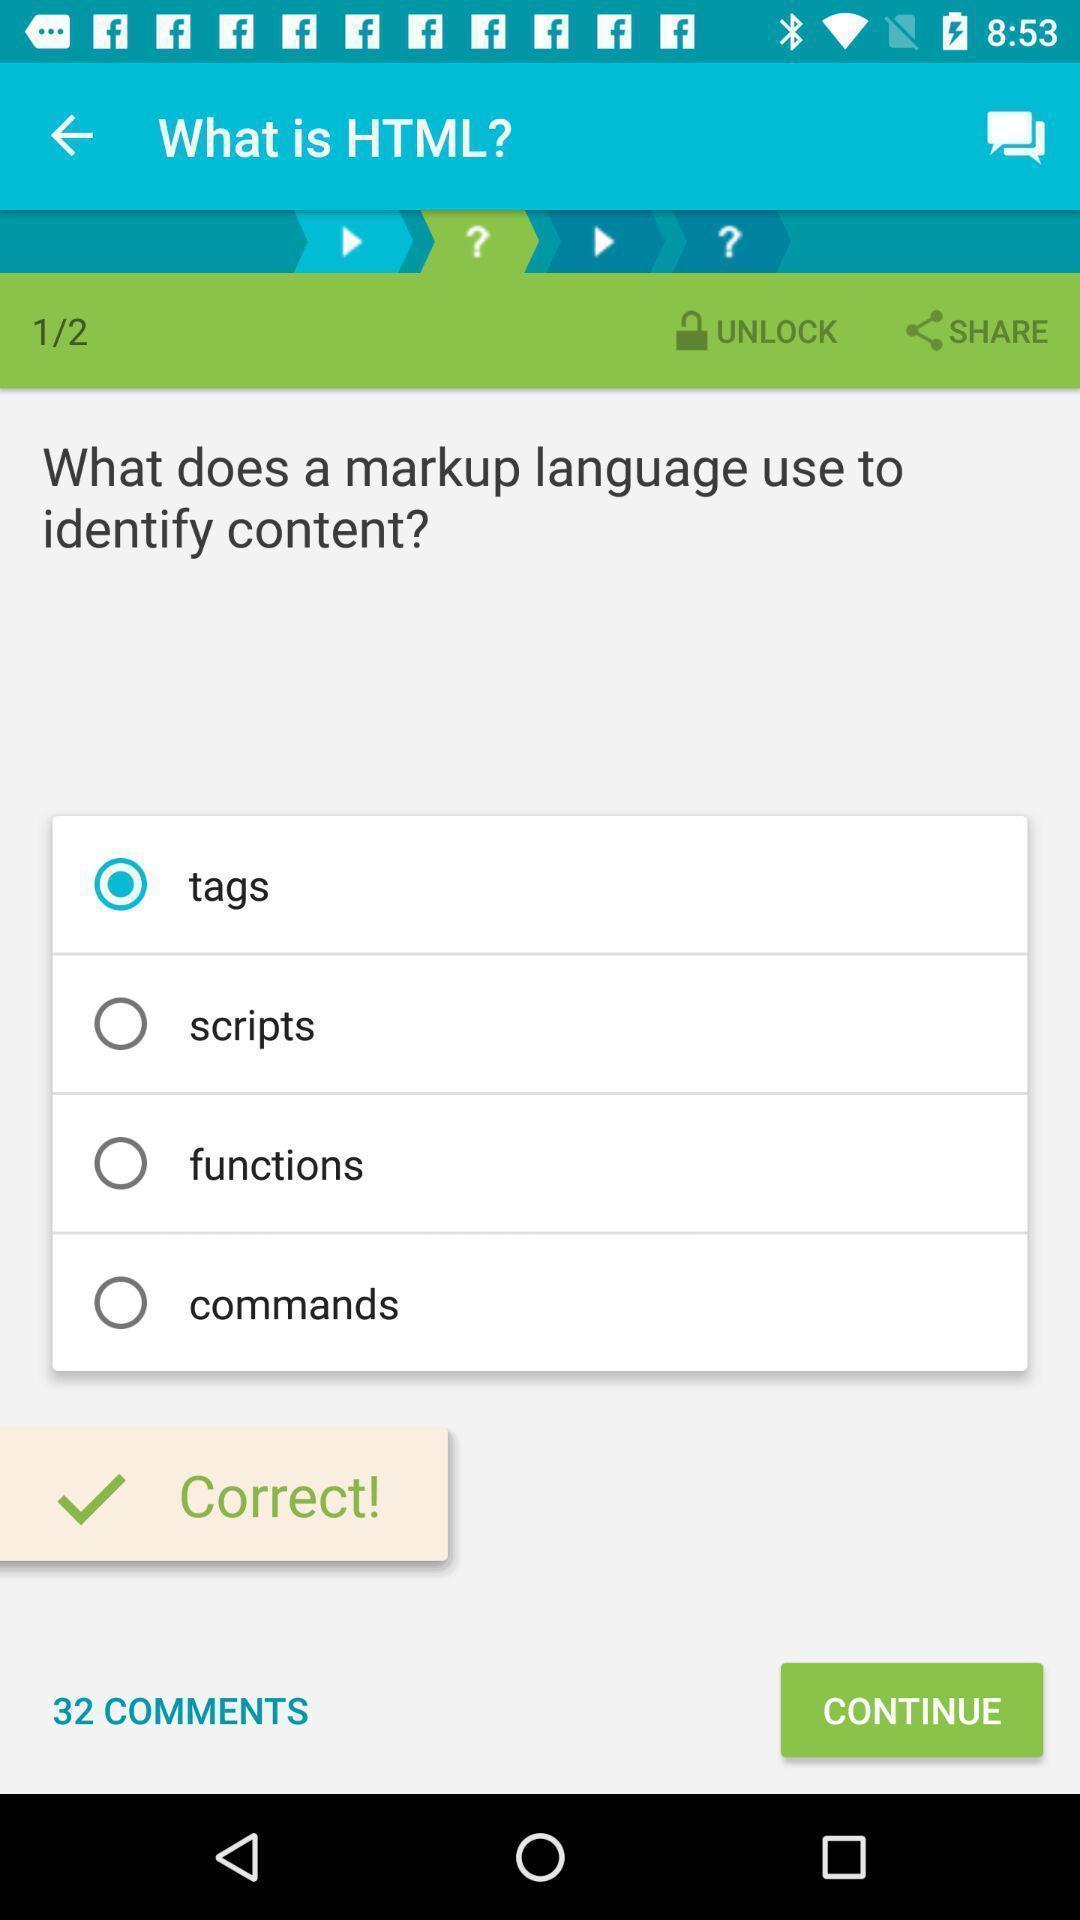Explain the elements present in this screenshot. Screen displaying the question and multiple options to select. 